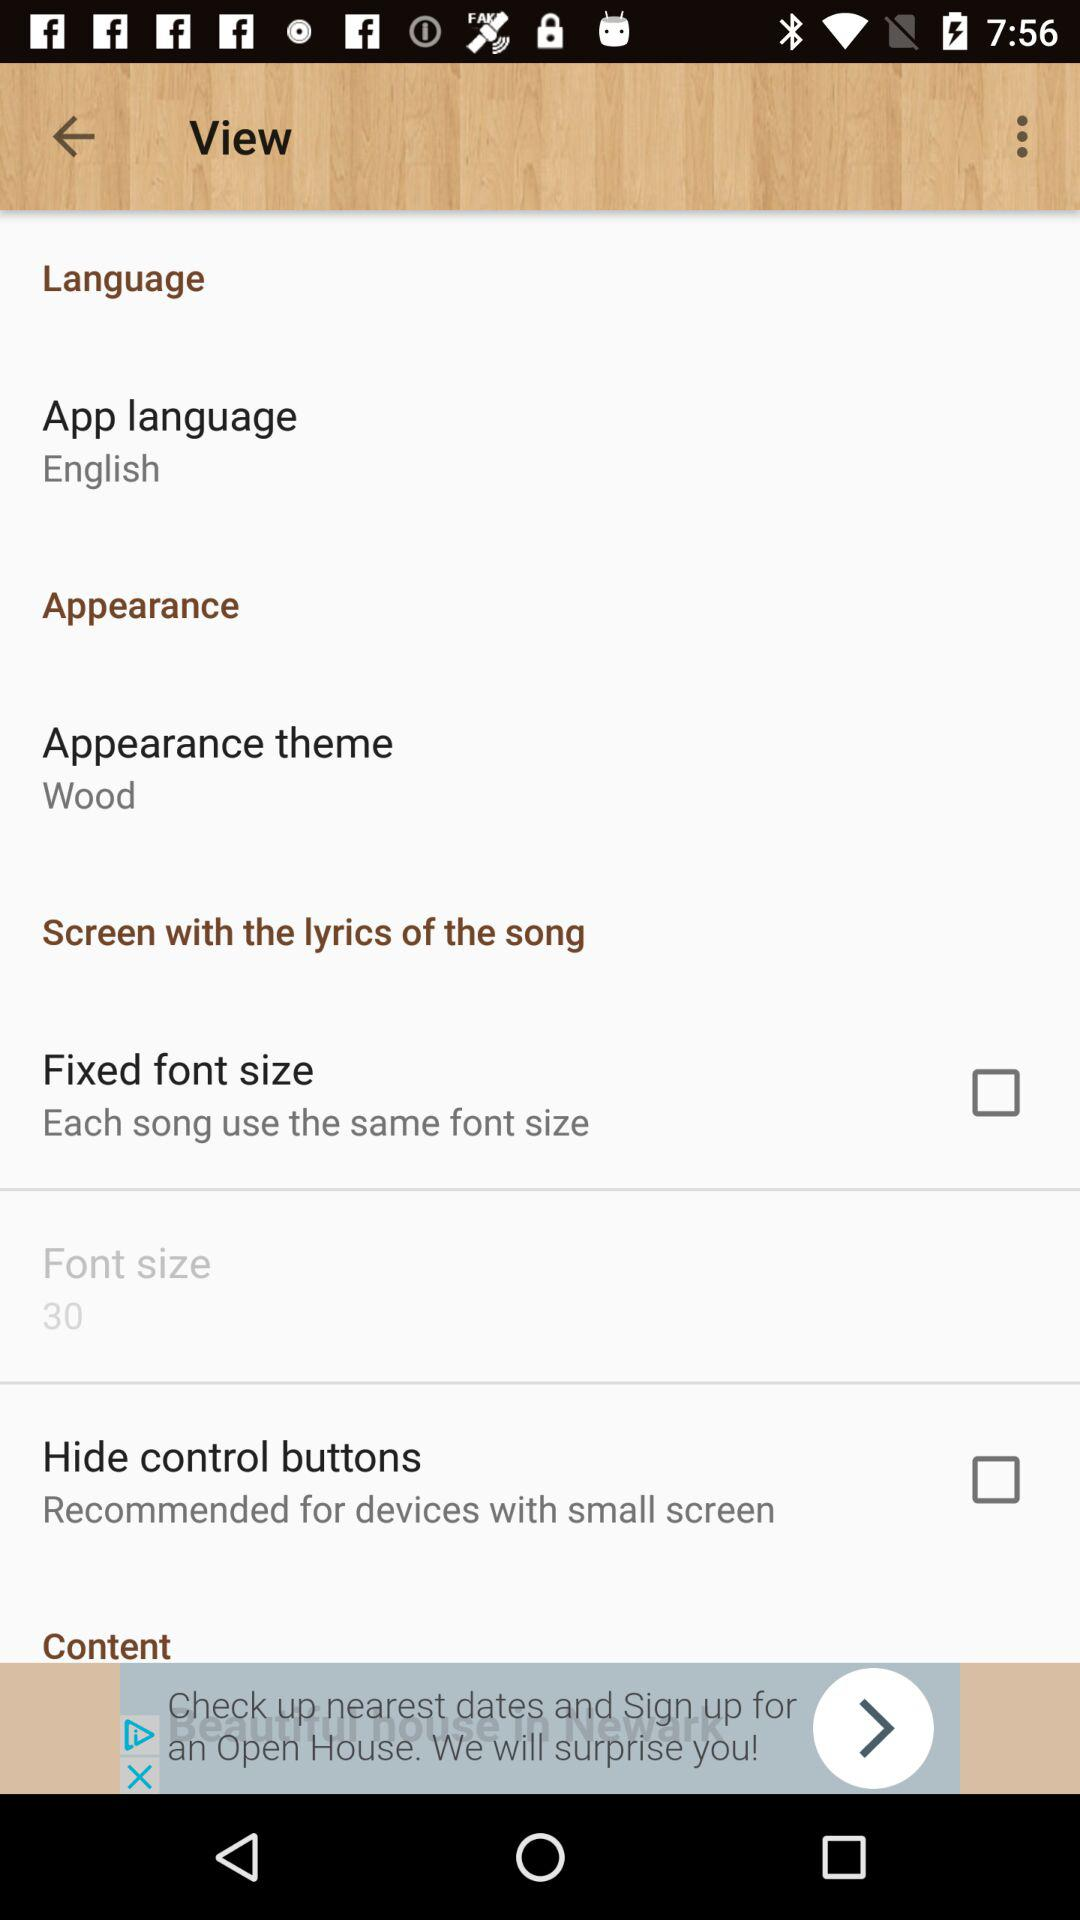What is the content?
When the provided information is insufficient, respond with <no answer>. <no answer> 